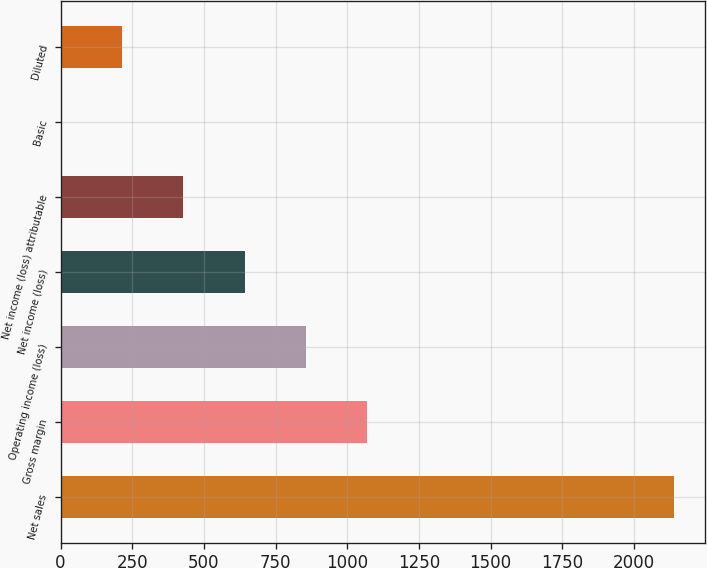<chart> <loc_0><loc_0><loc_500><loc_500><bar_chart><fcel>Net sales<fcel>Gross margin<fcel>Operating income (loss)<fcel>Net income (loss)<fcel>Net income (loss) attributable<fcel>Basic<fcel>Diluted<nl><fcel>2139<fcel>1069.52<fcel>855.63<fcel>641.74<fcel>427.85<fcel>0.07<fcel>213.96<nl></chart> 